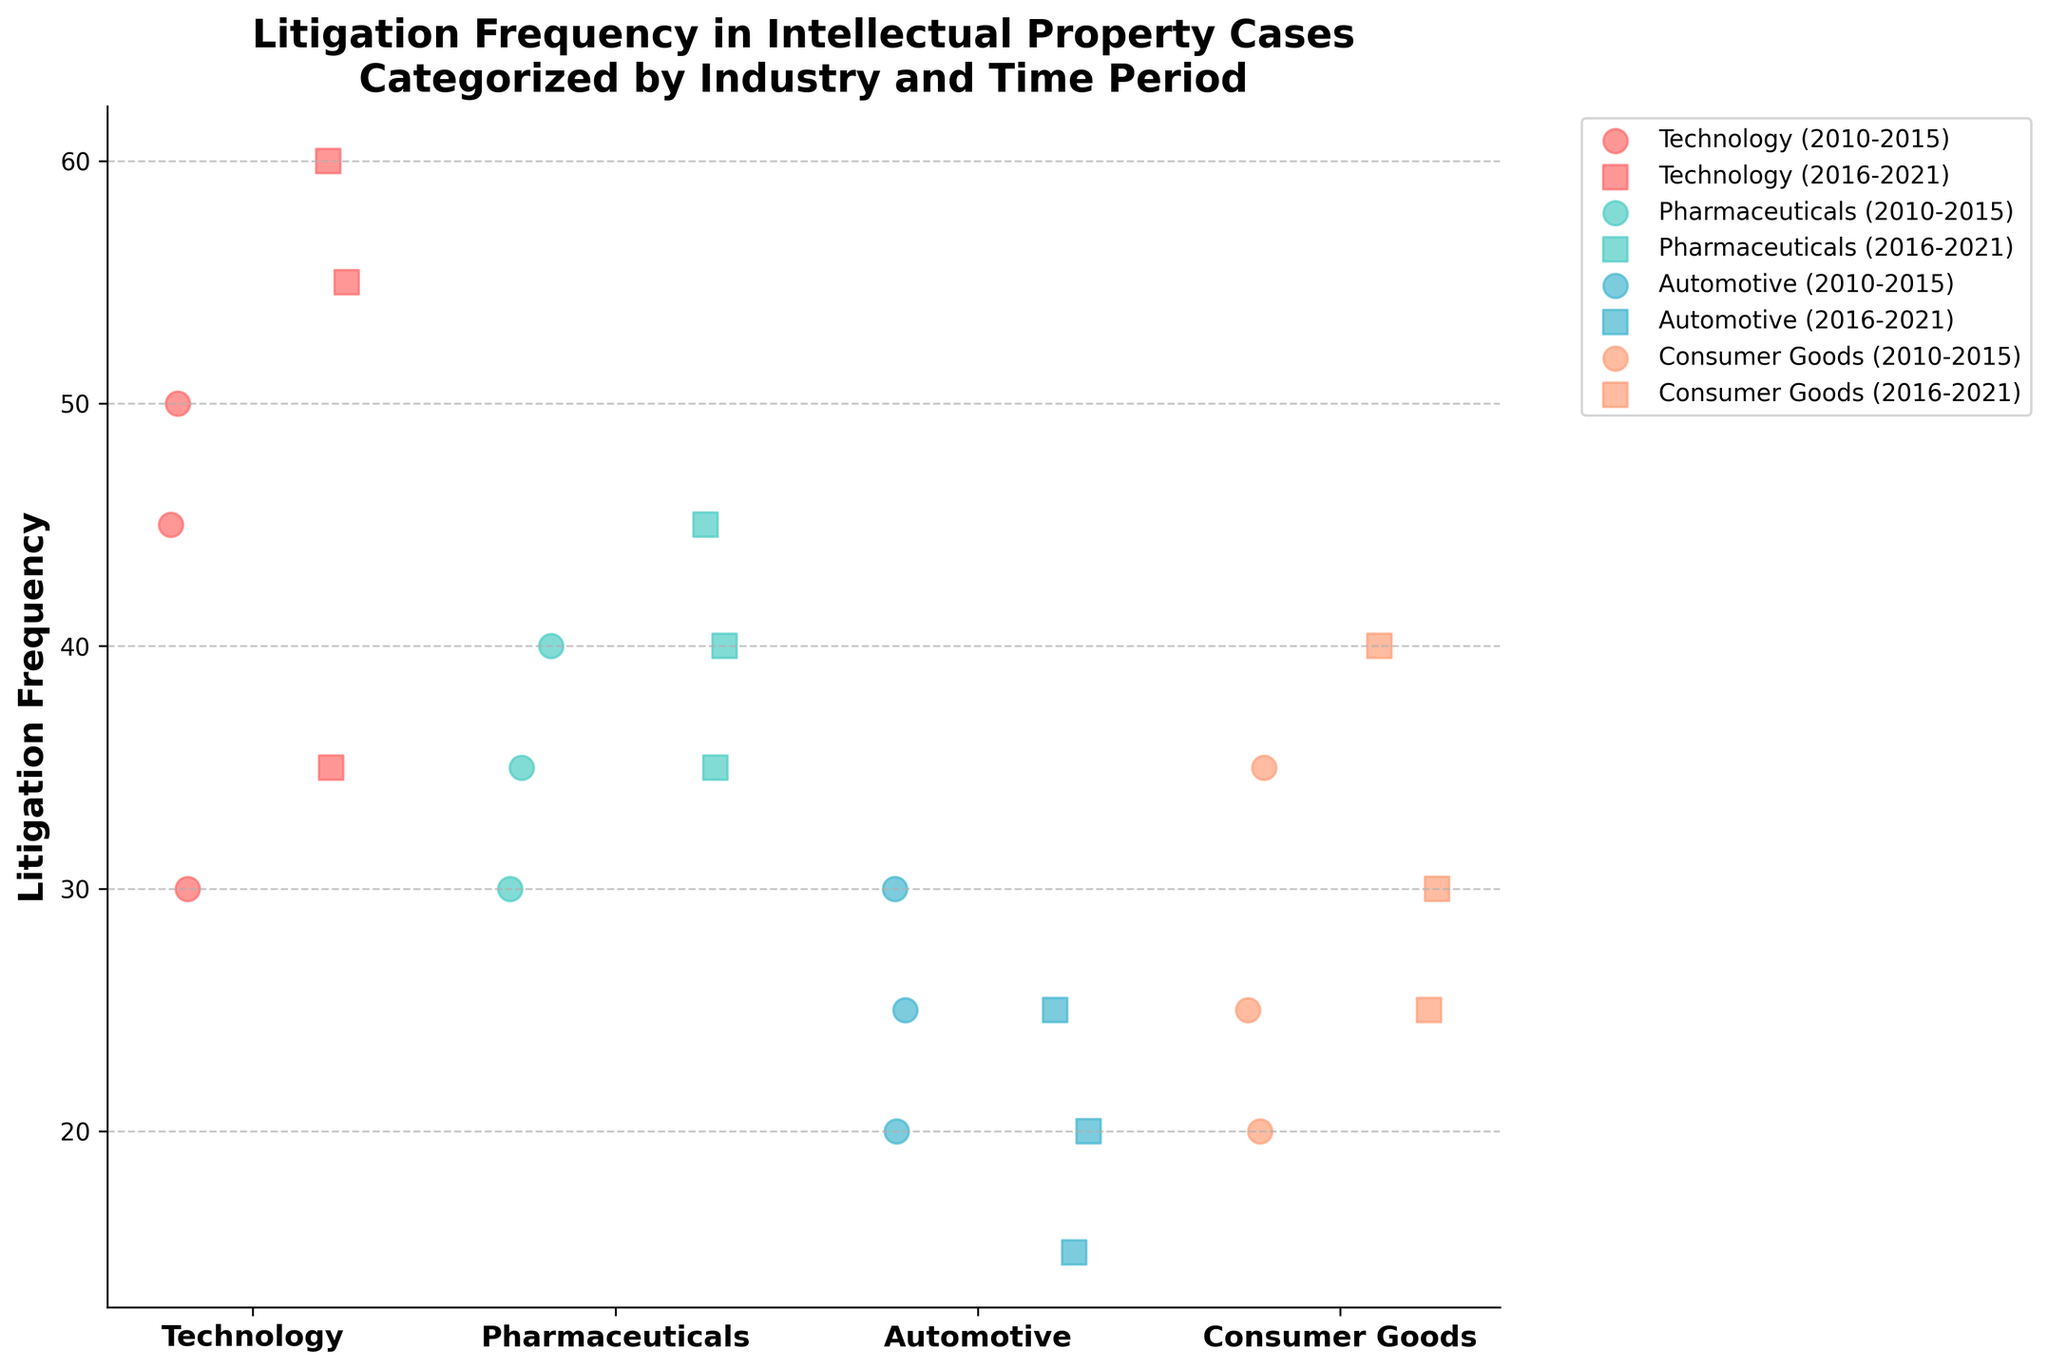What's the title of the figure? The title is usually placed at the top center of the figure. Reading it will give an overview of what the plot represents.
Answer: Litigation Frequency in Intellectual Property Cases Categorized by Industry and Time Period How many industries are represented in the plot? To find out the number of industries, look at the x-axis labels which list all the industries being analyzed.
Answer: Four Which industry has the highest litigation frequency in the 2016-2021 period? To identify this, look at the scatter points for each industry colored distinctly with markers for the 2016-2021 period. The highest y-value among them will show the industry with the highest litigation frequency.
Answer: Technology Compare the total litigation frequency for Technology and Pharmaceuticals across all periods. Which one is higher and by how much? Sum up the litigation frequencies for Technology (45 + 50 + 30 + 60 + 55 + 35 = 275) and Pharmaceuticals (40 + 35 + 30 + 45 + 40 + 35 = 225). Subtract the total for Pharmaceuticals from that of Technology to get the difference.
Answer: Technology, by 50 What's the average litigation frequency in the Automotive industry for the period 2010-2015? Add up the litigation frequencies for the Automotive industry in the 2010-2015 period and then divide by the number of data points (25 + 30 + 20 = 75; 75 / 3).
Answer: 25 Which company in the Consumer Goods industry shows the lowest litigation frequency in the 2010-2015 period? Look for the scatter points specific to the Consumer Goods industry in the 2010-2015 period. Find the lowest y-value among these points, which represents the lowest litigation frequency.
Answer: Colgate-Palmolive Does the average litigation frequency increase or decrease in the Pharmaceuticals industry from 2010-2015 to 2016-2021? Calculate the average for the periods (105/3 = 35 for 2010-2015 and 120/3 = 40 for 2016-2021). Compare these averages to see the trend.
Answer: Increase Which time period in the Automotive industry shows an overall decrease in litigation frequency compared to the other period? Compare the scatter points for the Automotive industry in both time periods. Determine which period has overall lower y-values.
Answer: 2016-2021 Across all periods and industries, which company appears most frequently? Count how many times each company's name appears across all the scatter points.
Answer: All companies appear twice each 